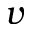Convert formula to latex. <formula><loc_0><loc_0><loc_500><loc_500>v</formula> 